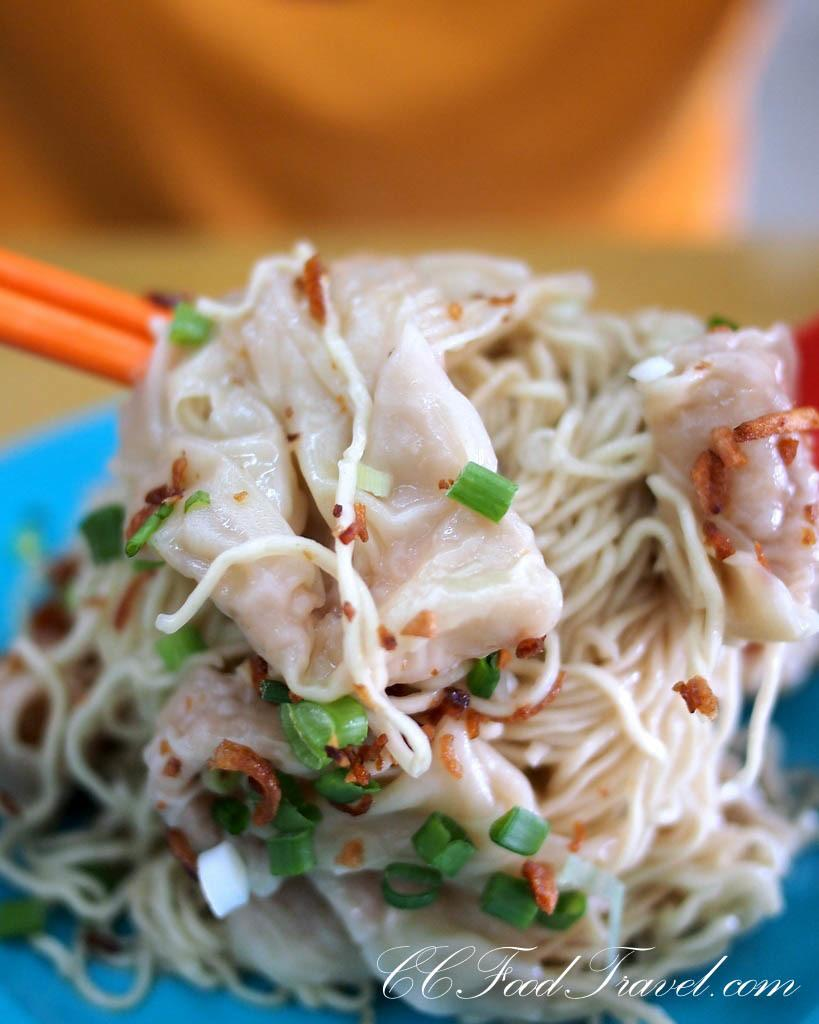What type of food is present in the image? There are noodles in the image. What color is the plate that holds the noodles? The plate containing the noodles is blue. What thrilling experience can be seen happening to the noodles in the image? There is no thrilling experience happening to the noodles in the image; they are simply on a blue plate. 